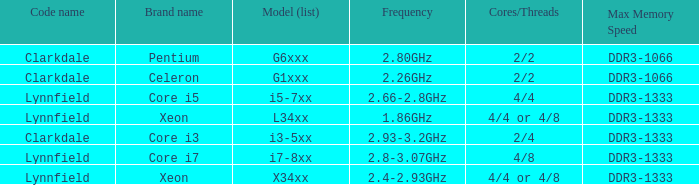What brand is model G6xxx? Pentium. 